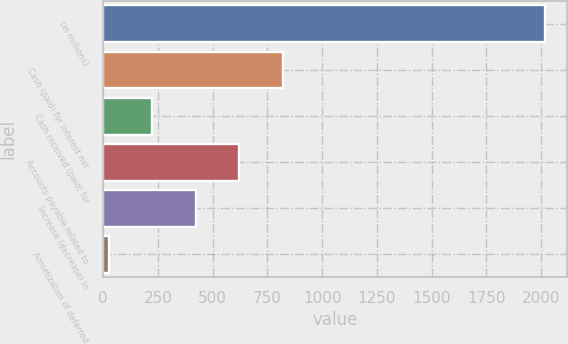Convert chart. <chart><loc_0><loc_0><loc_500><loc_500><bar_chart><fcel>(in millions)<fcel>Cash (paid) for interest net<fcel>Cash received (paid) for<fcel>Accounts payable related to<fcel>Increase (decrease) in<fcel>Amortization of deferred<nl><fcel>2016<fcel>821.22<fcel>223.83<fcel>622.09<fcel>422.96<fcel>24.7<nl></chart> 